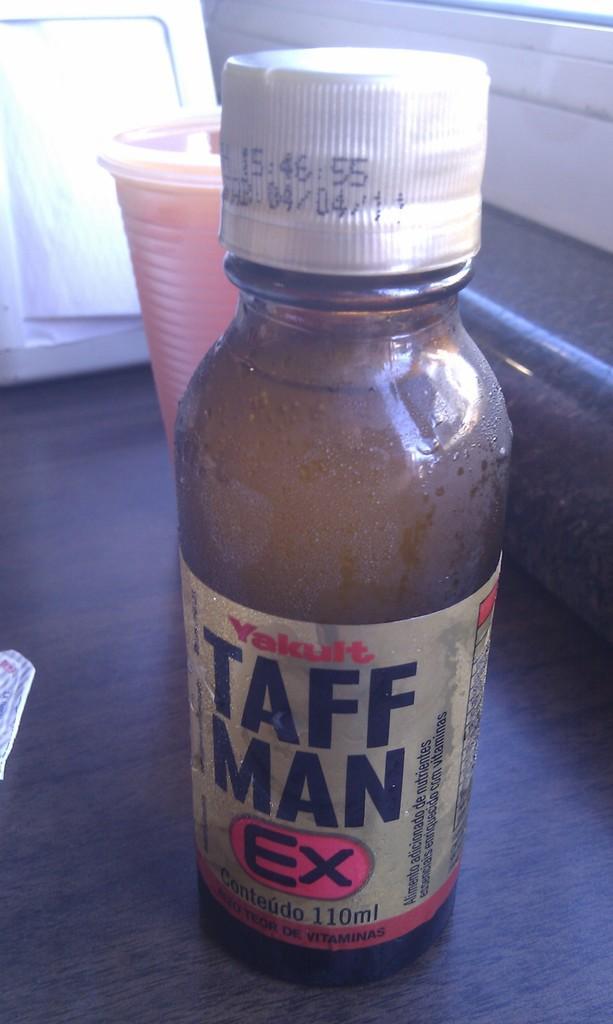How would you summarize this image in a sentence or two? In this image we can see beverage bottle and glass placed on the table. 